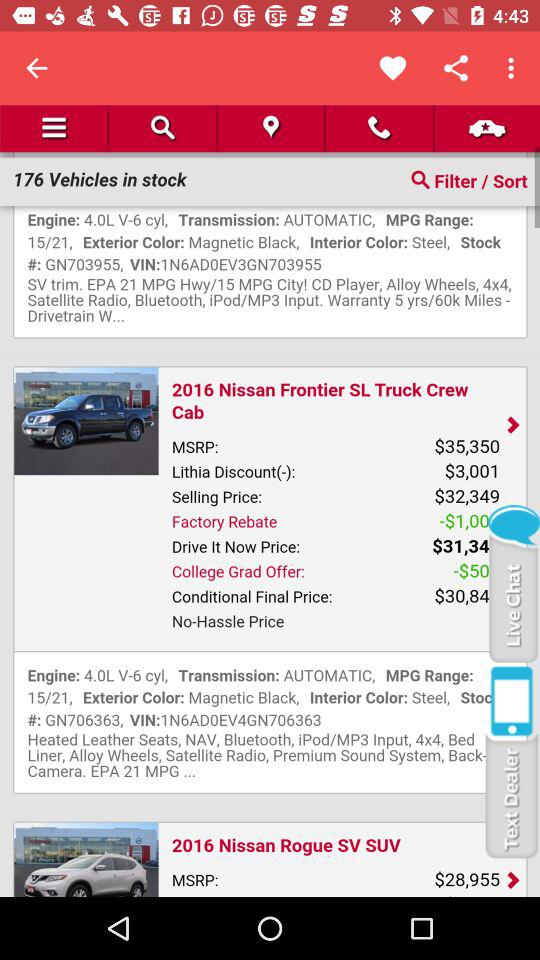How many vehicles are in stock? There are 176 vehicles in stock. 